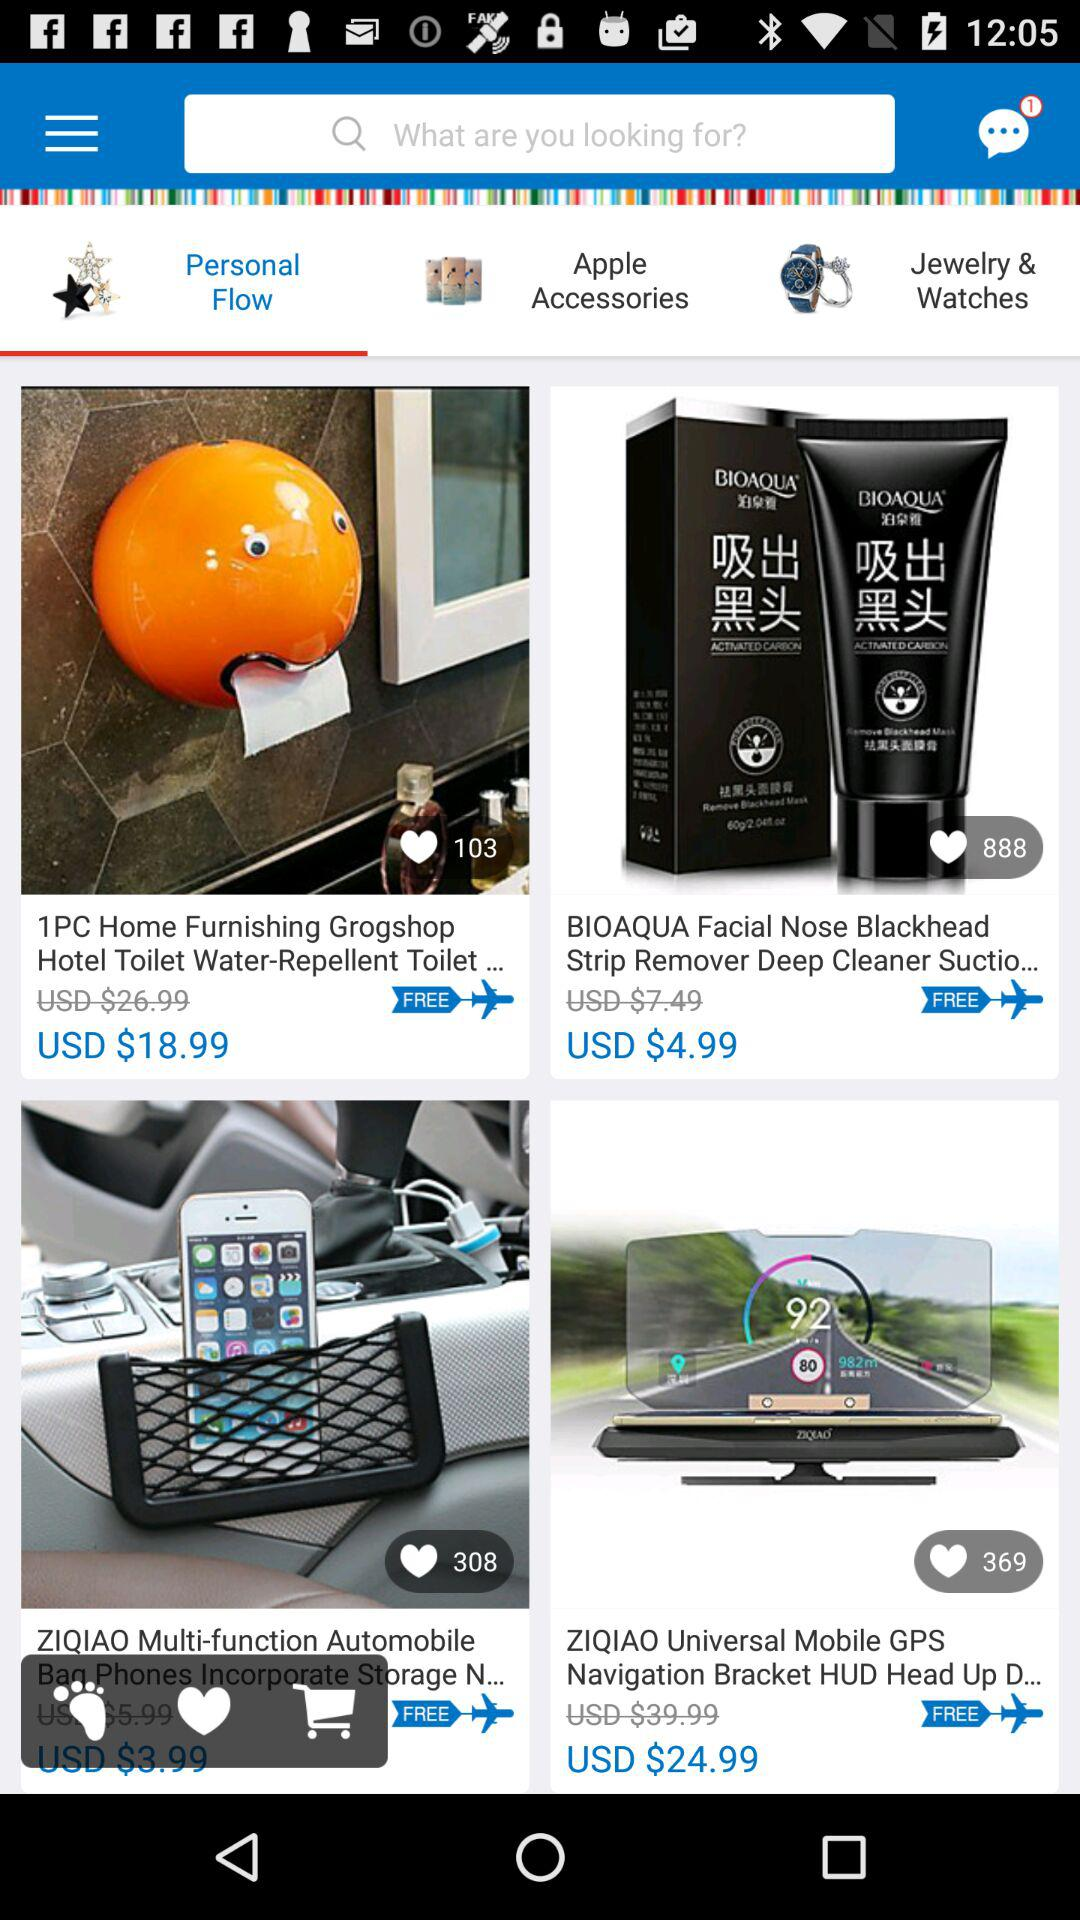How many likes for the "1PC Home Furnishing Grogshop Hotel Toilet Water-Repellent Toilet..."? The likes for the "1PC Home Furnishing Grogshop Hotel Toilet Water-Repellent Toilet..." are 103. 